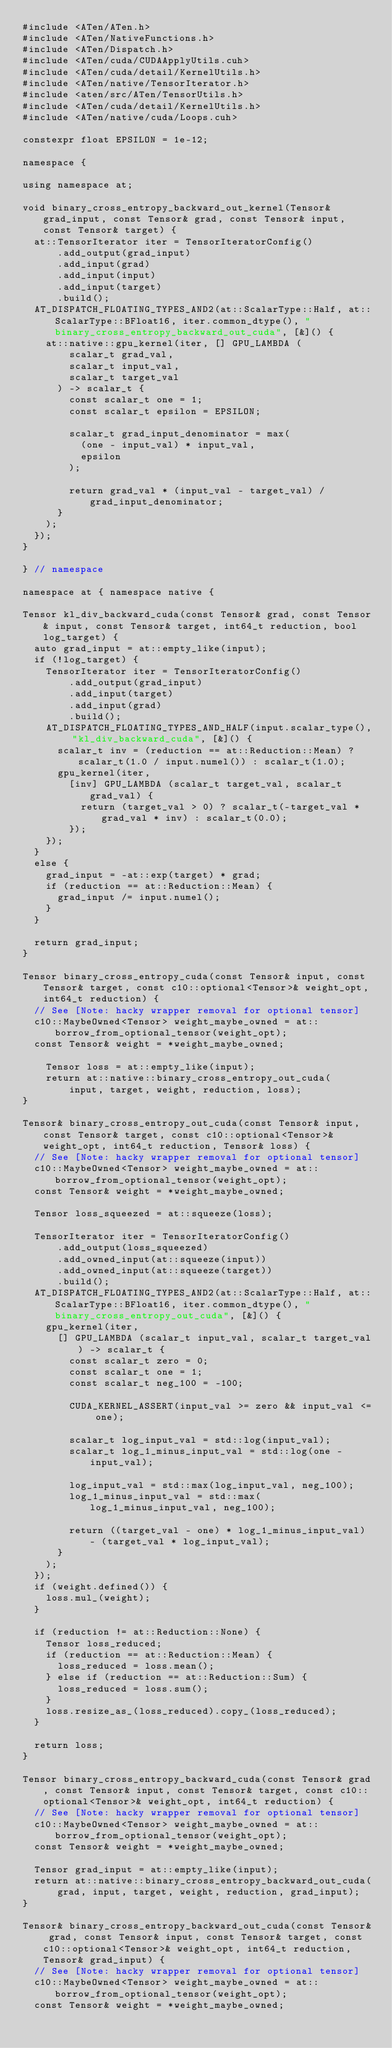<code> <loc_0><loc_0><loc_500><loc_500><_Cuda_>#include <ATen/ATen.h>
#include <ATen/NativeFunctions.h>
#include <ATen/Dispatch.h>
#include <ATen/cuda/CUDAApplyUtils.cuh>
#include <ATen/cuda/detail/KernelUtils.h>
#include <ATen/native/TensorIterator.h>
#include <aten/src/ATen/TensorUtils.h>
#include <ATen/cuda/detail/KernelUtils.h>
#include <ATen/native/cuda/Loops.cuh>

constexpr float EPSILON = 1e-12;

namespace {

using namespace at;

void binary_cross_entropy_backward_out_kernel(Tensor& grad_input, const Tensor& grad, const Tensor& input, const Tensor& target) {
  at::TensorIterator iter = TensorIteratorConfig()
      .add_output(grad_input)
      .add_input(grad)
      .add_input(input)
      .add_input(target)
      .build();
  AT_DISPATCH_FLOATING_TYPES_AND2(at::ScalarType::Half, at::ScalarType::BFloat16, iter.common_dtype(), "binary_cross_entropy_backward_out_cuda", [&]() {
    at::native::gpu_kernel(iter, [] GPU_LAMBDA (
        scalar_t grad_val,
        scalar_t input_val,
        scalar_t target_val
      ) -> scalar_t {
        const scalar_t one = 1;
        const scalar_t epsilon = EPSILON;

        scalar_t grad_input_denominator = max(
          (one - input_val) * input_val,
          epsilon
        );

        return grad_val * (input_val - target_val) / grad_input_denominator;
      }
    );
  });
}

} // namespace

namespace at { namespace native {

Tensor kl_div_backward_cuda(const Tensor& grad, const Tensor& input, const Tensor& target, int64_t reduction, bool log_target) {
  auto grad_input = at::empty_like(input);
  if (!log_target) {
    TensorIterator iter = TensorIteratorConfig()
        .add_output(grad_input)
        .add_input(target)
        .add_input(grad)
        .build();
    AT_DISPATCH_FLOATING_TYPES_AND_HALF(input.scalar_type(), "kl_div_backward_cuda", [&]() {
      scalar_t inv = (reduction == at::Reduction::Mean) ? scalar_t(1.0 / input.numel()) : scalar_t(1.0);
      gpu_kernel(iter,
        [inv] GPU_LAMBDA (scalar_t target_val, scalar_t grad_val) {
          return (target_val > 0) ? scalar_t(-target_val * grad_val * inv) : scalar_t(0.0);
        });
    });
  }
  else {
    grad_input = -at::exp(target) * grad;
    if (reduction == at::Reduction::Mean) {
      grad_input /= input.numel();
    }
  }

  return grad_input;
}

Tensor binary_cross_entropy_cuda(const Tensor& input, const Tensor& target, const c10::optional<Tensor>& weight_opt, int64_t reduction) {
  // See [Note: hacky wrapper removal for optional tensor]
  c10::MaybeOwned<Tensor> weight_maybe_owned = at::borrow_from_optional_tensor(weight_opt);
  const Tensor& weight = *weight_maybe_owned;

    Tensor loss = at::empty_like(input);
    return at::native::binary_cross_entropy_out_cuda(
        input, target, weight, reduction, loss);
}

Tensor& binary_cross_entropy_out_cuda(const Tensor& input, const Tensor& target, const c10::optional<Tensor>& weight_opt, int64_t reduction, Tensor& loss) {
  // See [Note: hacky wrapper removal for optional tensor]
  c10::MaybeOwned<Tensor> weight_maybe_owned = at::borrow_from_optional_tensor(weight_opt);
  const Tensor& weight = *weight_maybe_owned;

  Tensor loss_squeezed = at::squeeze(loss);

  TensorIterator iter = TensorIteratorConfig()
      .add_output(loss_squeezed)
      .add_owned_input(at::squeeze(input))
      .add_owned_input(at::squeeze(target))
      .build();
  AT_DISPATCH_FLOATING_TYPES_AND2(at::ScalarType::Half, at::ScalarType::BFloat16, iter.common_dtype(), "binary_cross_entropy_out_cuda", [&]() {
    gpu_kernel(iter,
      [] GPU_LAMBDA (scalar_t input_val, scalar_t target_val) -> scalar_t {
        const scalar_t zero = 0;
        const scalar_t one = 1;
        const scalar_t neg_100 = -100;

        CUDA_KERNEL_ASSERT(input_val >= zero && input_val <= one);

        scalar_t log_input_val = std::log(input_val);
        scalar_t log_1_minus_input_val = std::log(one - input_val);

        log_input_val = std::max(log_input_val, neg_100);
        log_1_minus_input_val = std::max(log_1_minus_input_val, neg_100);

        return ((target_val - one) * log_1_minus_input_val) - (target_val * log_input_val);
      }
    );
  });
  if (weight.defined()) {
    loss.mul_(weight);
  }

  if (reduction != at::Reduction::None) {
    Tensor loss_reduced;
    if (reduction == at::Reduction::Mean) {
      loss_reduced = loss.mean();
    } else if (reduction == at::Reduction::Sum) {
      loss_reduced = loss.sum();
    }
    loss.resize_as_(loss_reduced).copy_(loss_reduced);
  }

  return loss;
}

Tensor binary_cross_entropy_backward_cuda(const Tensor& grad, const Tensor& input, const Tensor& target, const c10::optional<Tensor>& weight_opt, int64_t reduction) {
  // See [Note: hacky wrapper removal for optional tensor]
  c10::MaybeOwned<Tensor> weight_maybe_owned = at::borrow_from_optional_tensor(weight_opt);
  const Tensor& weight = *weight_maybe_owned;

  Tensor grad_input = at::empty_like(input);
  return at::native::binary_cross_entropy_backward_out_cuda(
      grad, input, target, weight, reduction, grad_input);
}

Tensor& binary_cross_entropy_backward_out_cuda(const Tensor& grad, const Tensor& input, const Tensor& target, const c10::optional<Tensor>& weight_opt, int64_t reduction, Tensor& grad_input) {
  // See [Note: hacky wrapper removal for optional tensor]
  c10::MaybeOwned<Tensor> weight_maybe_owned = at::borrow_from_optional_tensor(weight_opt);
  const Tensor& weight = *weight_maybe_owned;
</code> 